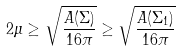<formula> <loc_0><loc_0><loc_500><loc_500>2 \mu \geq \sqrt { \frac { A ( \Sigma ) } { 1 6 \pi } } \geq \sqrt { \frac { A ( \Sigma _ { 1 } ) } { 1 6 \pi } }</formula> 